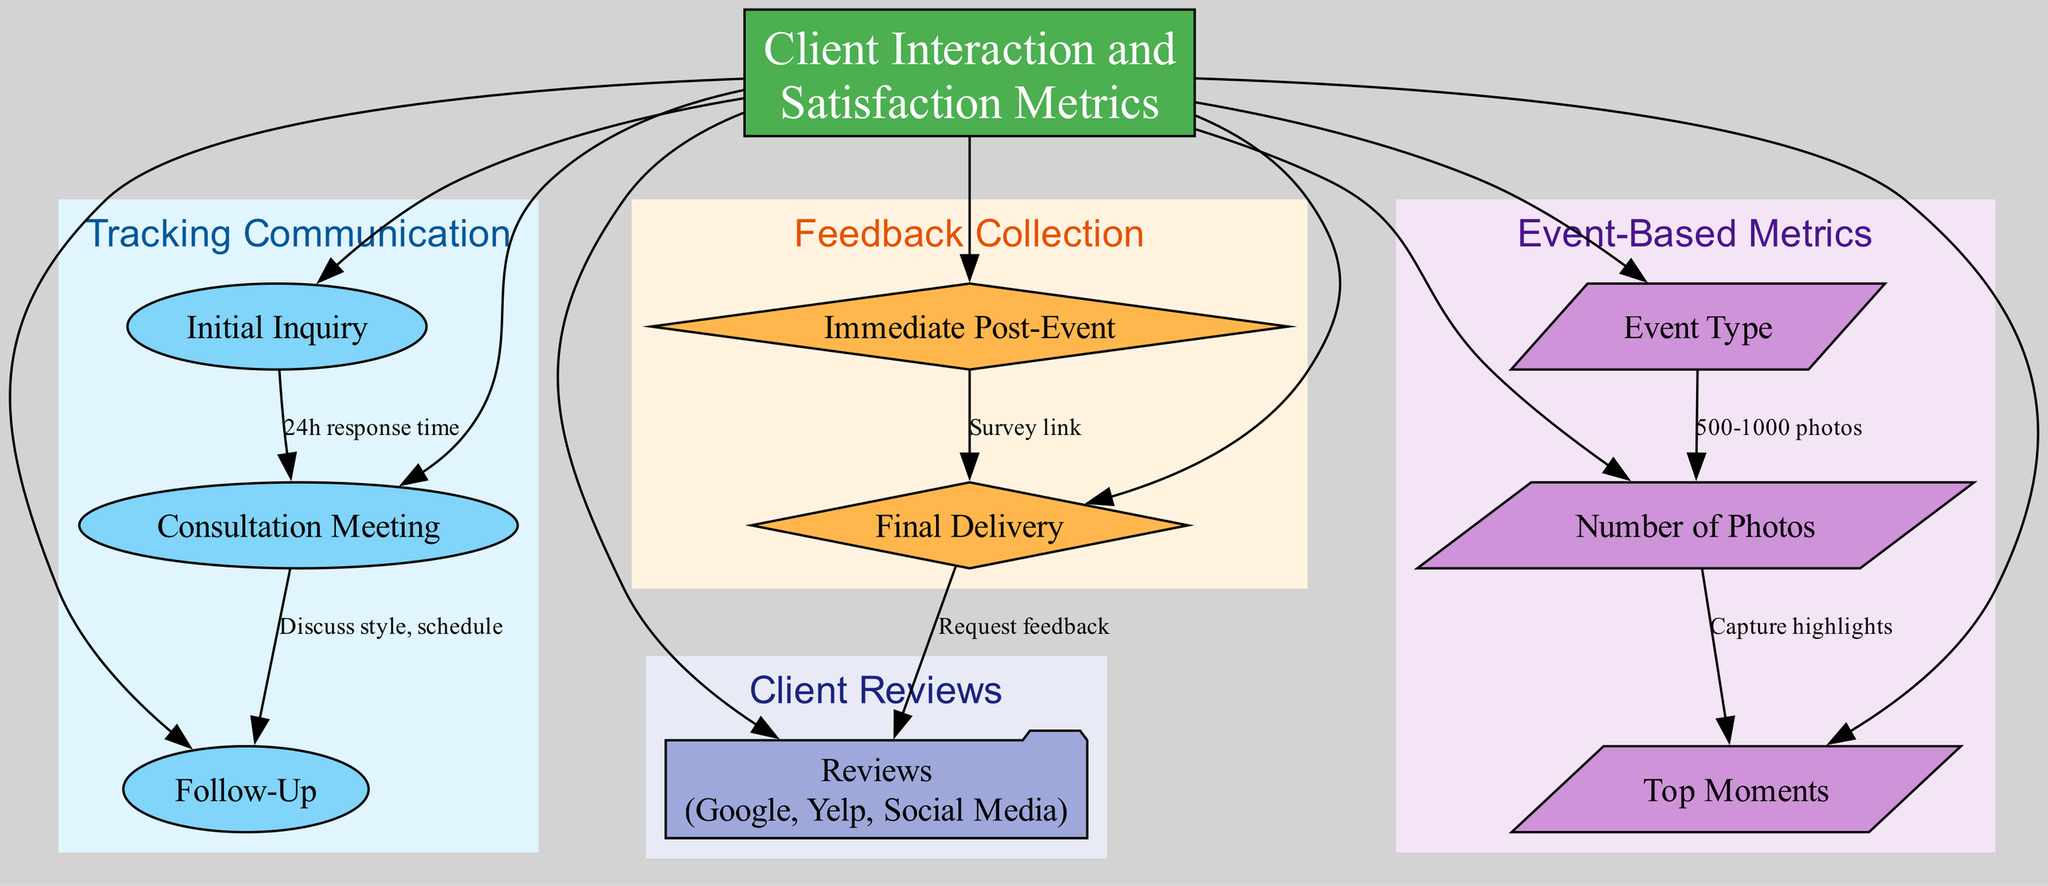What are the three methods of initial inquiry? The diagram lists the methods for initial inquiry under "Tracking Communication" as "Email/Phone." Thus, the answer is directly from that node.
Answer: Email/Phone How long is the response time for the initial inquiry? The response time for the initial inquiry is specified in the diagram. To find this, I look under the "Initial Inquiry" node, which states a "24 hours" response time.
Answer: 24 hours What are the two platforms used for consultation meetings? Under the "Consultation Meeting" node in "Tracking Communication," it explicitly states the platforms used for meetings are "Zoom/In-Person." Thus, I can directly answer this by reviewing that information.
Answer: Zoom/In-Person What is the follow-up method before the event? To find the follow-up method, I check the "Follow-Up" node under "Tracking Communication," which shows it is either "Email/Phone." Therefore, this is a straightforward identification from the diagram.
Answer: Email/Phone What are the two questions asked in the immediate post-event feedback? The questions asked are located in the "Immediate Post-Event" node under "Feedback Collection." Here I find listed questions that include "Initial Impressions" and "Specific Moment Captures." This entails checking the relevant section for specifics.
Answer: Initial Impressions, Specific Moment Captures How many platforms are used for client reviews? In the "Client Reviews" section, the node lists the platforms as "Google Reviews, Yelp, Social Media Pages," indicating a total of three. As I count each of the platforms mentioned, I reach the answer based on the direct enumeration from that node.
Answer: 3 What is the purpose of the final delivery method? The "Final Delivery" node specifies that it’s for delivering photos via "Email/Link to Online Gallery," followed by a request for feedback. The purpose is delivery, involving sending images and a survey link, hence connecting the two pieces of information.
Answer: Deliver photos and request feedback What are the top three moments captured during events? Checking the node "Top Moments" under "Event-Based Metrics," it lists "Concert Highlights," "Group Photos," and "Fan Interactions." Each moment is detailed in that section, allowing for easy identification of the three primary moments.
Answer: Concert Highlights, Group Photos, Fan Interactions How many nodes are there in total within the diagram? To find the total number of nodes, I count each distinct node displayed throughout all sections of the diagram. Here, the main node and each category’s nodes are counted, leading to a total sum which is calculated to be 10. This can be confirmed by checking each cluster's nodes.
Answer: 10 